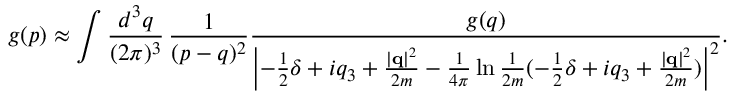Convert formula to latex. <formula><loc_0><loc_0><loc_500><loc_500>g ( p ) \approx \int \frac { d ^ { 3 } q } { ( 2 \pi ) ^ { 3 } } \, \frac { 1 } { ( p - q ) ^ { 2 } } \frac { g ( q ) } { \left | - \frac { 1 } { 2 } \delta + i q _ { 3 } + \frac { \left | { q } \right | ^ { 2 } } { 2 m } - \frac { 1 } { 4 \pi } \ln \frac { 1 } { 2 m } ( - \frac { 1 } { 2 } \delta + i q _ { 3 } + \frac { \left | { q } \right | ^ { 2 } } { 2 m } ) \right | ^ { 2 } } .</formula> 